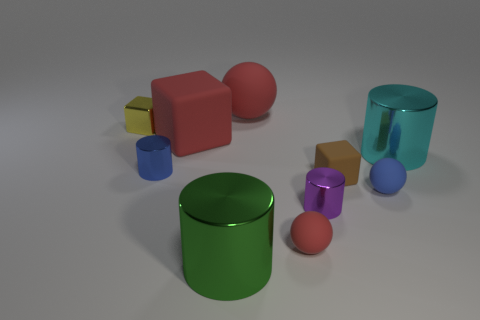Subtract all tiny blocks. How many blocks are left? 1 Subtract all gray cylinders. Subtract all blue blocks. How many cylinders are left? 4 Subtract all blocks. How many objects are left? 7 Subtract all large green objects. Subtract all purple things. How many objects are left? 8 Add 7 blue objects. How many blue objects are left? 9 Add 7 big green objects. How many big green objects exist? 8 Subtract 0 yellow spheres. How many objects are left? 10 